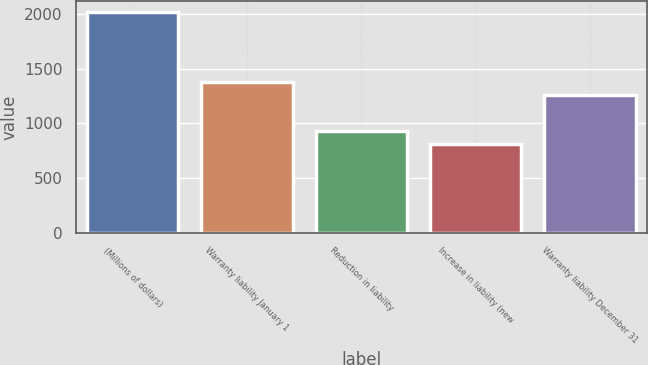Convert chart to OTSL. <chart><loc_0><loc_0><loc_500><loc_500><bar_chart><fcel>(Millions of dollars)<fcel>Warranty liability January 1<fcel>Reduction in liability<fcel>Increase in liability (new<fcel>Warranty liability December 31<nl><fcel>2016<fcel>1378.3<fcel>933.3<fcel>813<fcel>1258<nl></chart> 